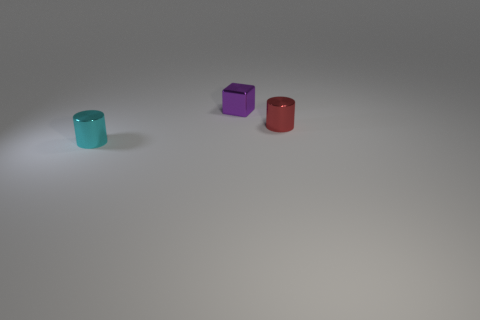What number of spheres are purple things or tiny objects?
Offer a terse response. 0. Is the number of purple spheres greater than the number of cyan metal cylinders?
Your answer should be compact. No. How many cyan cylinders are the same size as the red cylinder?
Provide a succinct answer. 1. What number of things are metal cylinders on the left side of the tiny purple object or purple objects?
Offer a very short reply. 2. Is the number of tiny purple cubes less than the number of tiny brown matte spheres?
Provide a succinct answer. No. There is a small cyan thing that is made of the same material as the small red thing; what shape is it?
Ensure brevity in your answer.  Cylinder. There is a small cube; are there any small things on the right side of it?
Keep it short and to the point. Yes. Are there fewer small metallic cylinders that are left of the red cylinder than small green metal cubes?
Keep it short and to the point. No. What is the purple object made of?
Keep it short and to the point. Metal. The cube has what color?
Ensure brevity in your answer.  Purple. 